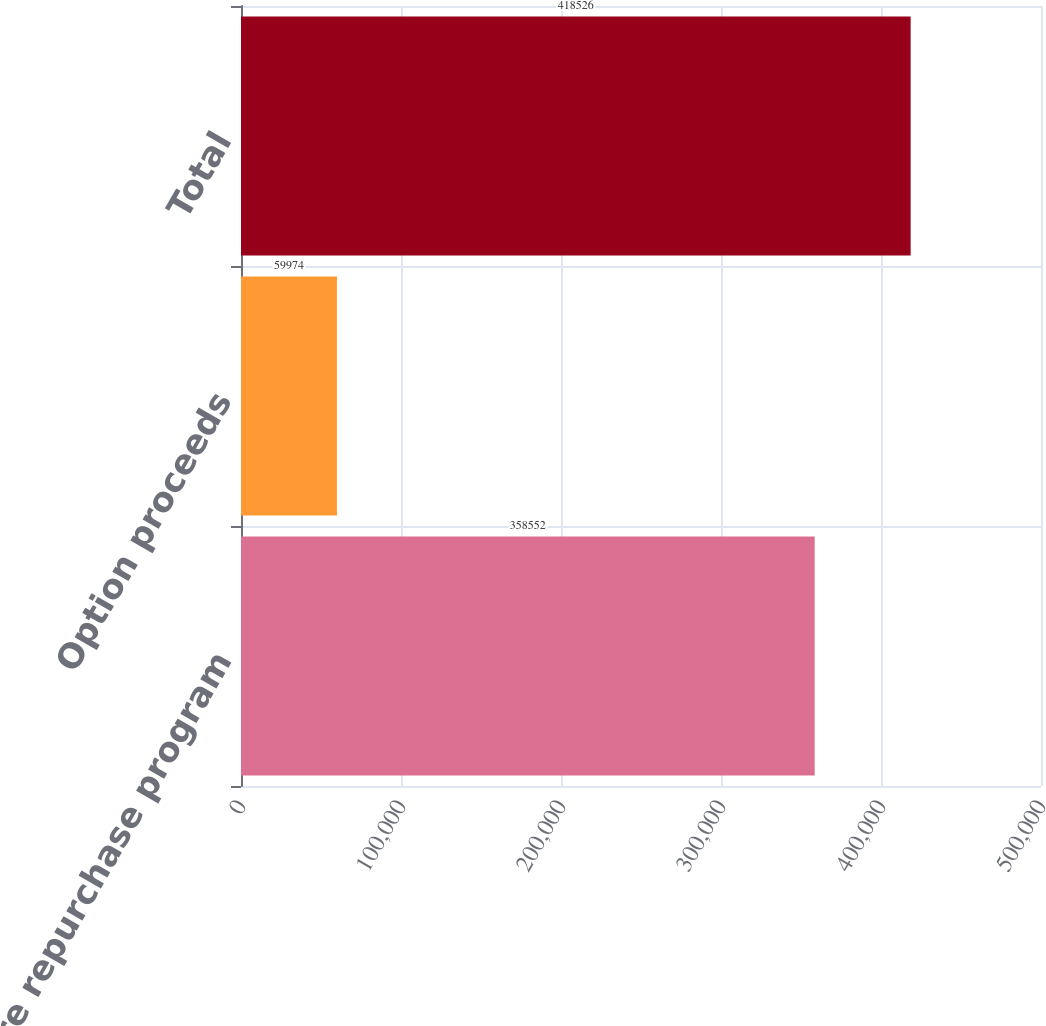<chart> <loc_0><loc_0><loc_500><loc_500><bar_chart><fcel>Share repurchase program<fcel>Option proceeds<fcel>Total<nl><fcel>358552<fcel>59974<fcel>418526<nl></chart> 